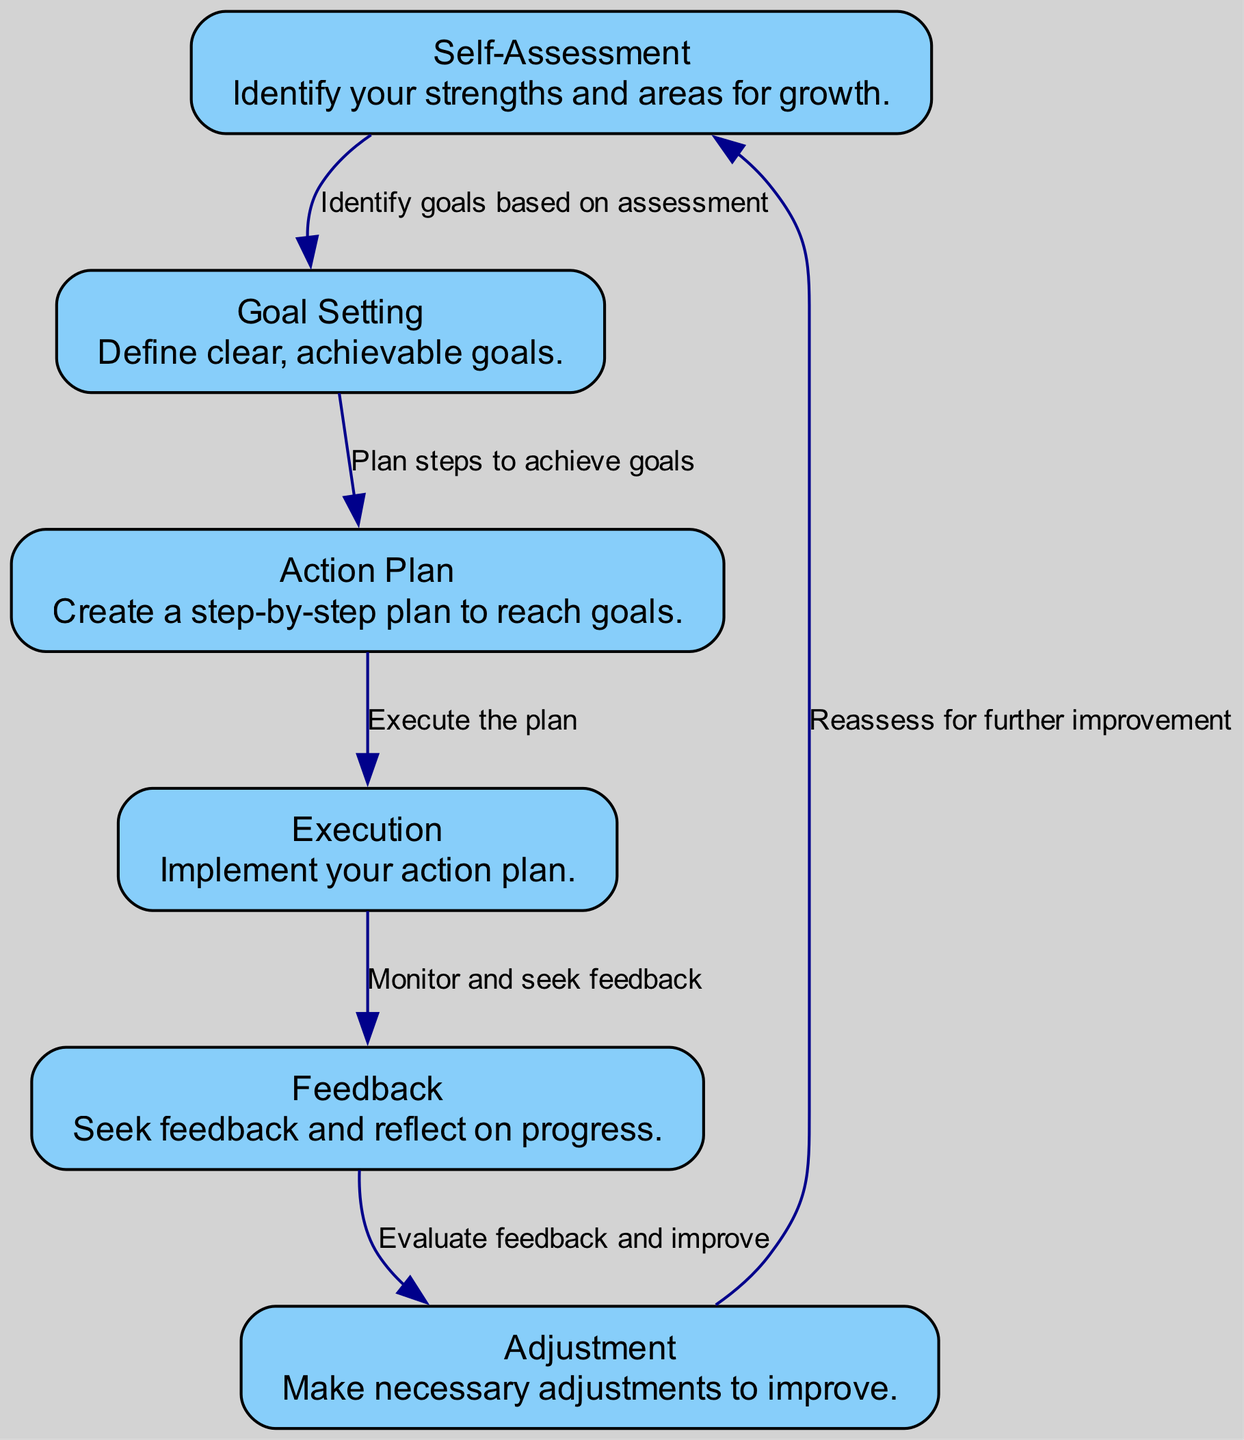What is the first step in the self-reflection cycle? The first step in the cycle is labeled "Self-Assessment," which emphasizes identifying one's strengths and areas for growth.
Answer: Self-Assessment How many nodes are in the diagram? The diagram contains a total of six nodes, which represent distinct stages of the self-reflection and improvement loop.
Answer: Six What is the relationship between "Execution" and "Feedback"? The edge connecting "Execution" to "Feedback" indicates that during the execution phase, one should monitor their progress and seek feedback.
Answer: Monitor and seek feedback What action follows "Feedback" in the cycle? The action that follows "Feedback" is "Adjustment," where one evaluates feedback received and makes improvements.
Answer: Adjustment Which node is related to defining goals? The node related to defining goals is "Goal Setting," which focuses on establishing clear and achievable goals based on self-assessment.
Answer: Goal Setting What process occurs after "Adjustment"? After "Adjustment," the process involves returning to "Self-Assessment" for further improvement and reassessment of one's progress.
Answer: Self-Assessment How does "Goal Setting" connect to "Action Plan"? The connection between "Goal Setting" and "Action Plan" signifies that one must plan steps to achieve the defined goals.
Answer: Plan steps to achieve goals What does the "Feedback" node encourage individuals to do? The "Feedback" node encourages individuals to seek feedback and reflect on their progress during their self-improvement journey.
Answer: Seek feedback and reflect on progress 